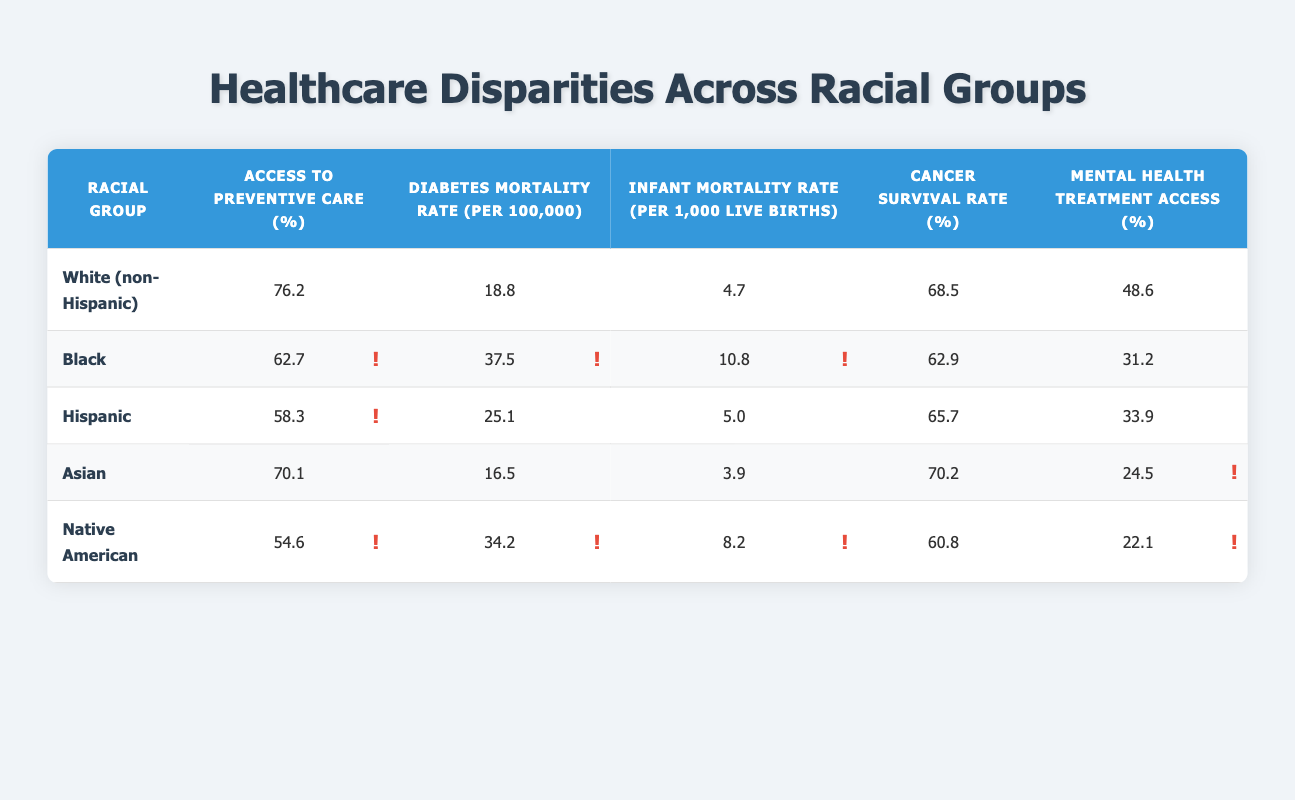What is the Access to Preventive Care percentage for Black individuals? The table directly lists the Access to Preventive Care percentage for Black individuals as 62.7%.
Answer: 62.7% Which racial group has the highest Cancer Survival Rate? By comparing the Cancer Survival Rates listed in the table, White (non-Hispanic) has the highest rate at 68.5%.
Answer: 68.5% What is the difference in Diabetes Mortality Rate between Hispanic and Native American populations? The Diabetes Mortality Rate for Hispanics is 25.1 and for Native Americans is 34.2. The difference is calculated as 34.2 - 25.1 = 9.1.
Answer: 9.1 Is the Infant Mortality Rate for Asians lower than that for Native Americans? The Infant Mortality Rate for Asians is 3.9 and for Native Americans is 8.2. Since 3.9 is less than 8.2, the statement is true.
Answer: Yes What is the average Access to Preventive Care percentage across all racial groups? To find the average, sum the percentages (76.2 + 62.7 + 58.3 + 70.1 + 54.6) = 321.9. There are 5 groups, so the average is 321.9 / 5 = 64.38.
Answer: 64.38 Which racial group experiences the highest rate of Mental Health Treatment Access? By looking at the Mental Health Treatment Access percentages, the highest percentage is for White (non-Hispanic) at 48.6%.
Answer: 48.6% Does the Cancer Survival Rate for Native American individuals exceed that of Black individuals? The Cancer Survival Rate for Native Americans is 60.8% while for Blacks it is 62.9%. Since 60.8 is less than 62.9, the statement is false.
Answer: No Which racial group has both the highest Access to Preventive Care and the lowest Diabetes Mortality Rate? Analyzing the table, White (non-Hispanic) has the highest Access to Preventive Care (76.2%) and the lowest Diabetes Mortality Rate (18.8).
Answer: White (non-Hispanic) 